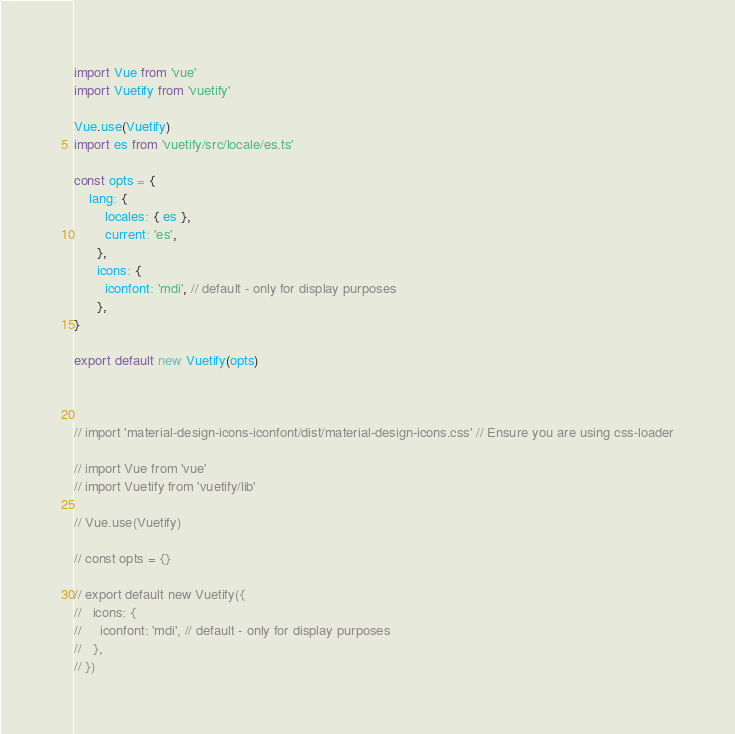Convert code to text. <code><loc_0><loc_0><loc_500><loc_500><_JavaScript_>import Vue from 'vue'
import Vuetify from 'vuetify'

Vue.use(Vuetify)
import es from 'vuetify/src/locale/es.ts'

const opts = {
    lang: {
        locales: { es },
        current: 'es',
      },
      icons: {
        iconfont: 'mdi', // default - only for display purposes
      },
}

export default new Vuetify(opts)



// import 'material-design-icons-iconfont/dist/material-design-icons.css' // Ensure you are using css-loader

// import Vue from 'vue'
// import Vuetify from 'vuetify/lib'

// Vue.use(Vuetify)

// const opts = {}

// export default new Vuetify({
//   icons: {
//     iconfont: 'mdi', // default - only for display purposes
//   },
// })
</code> 